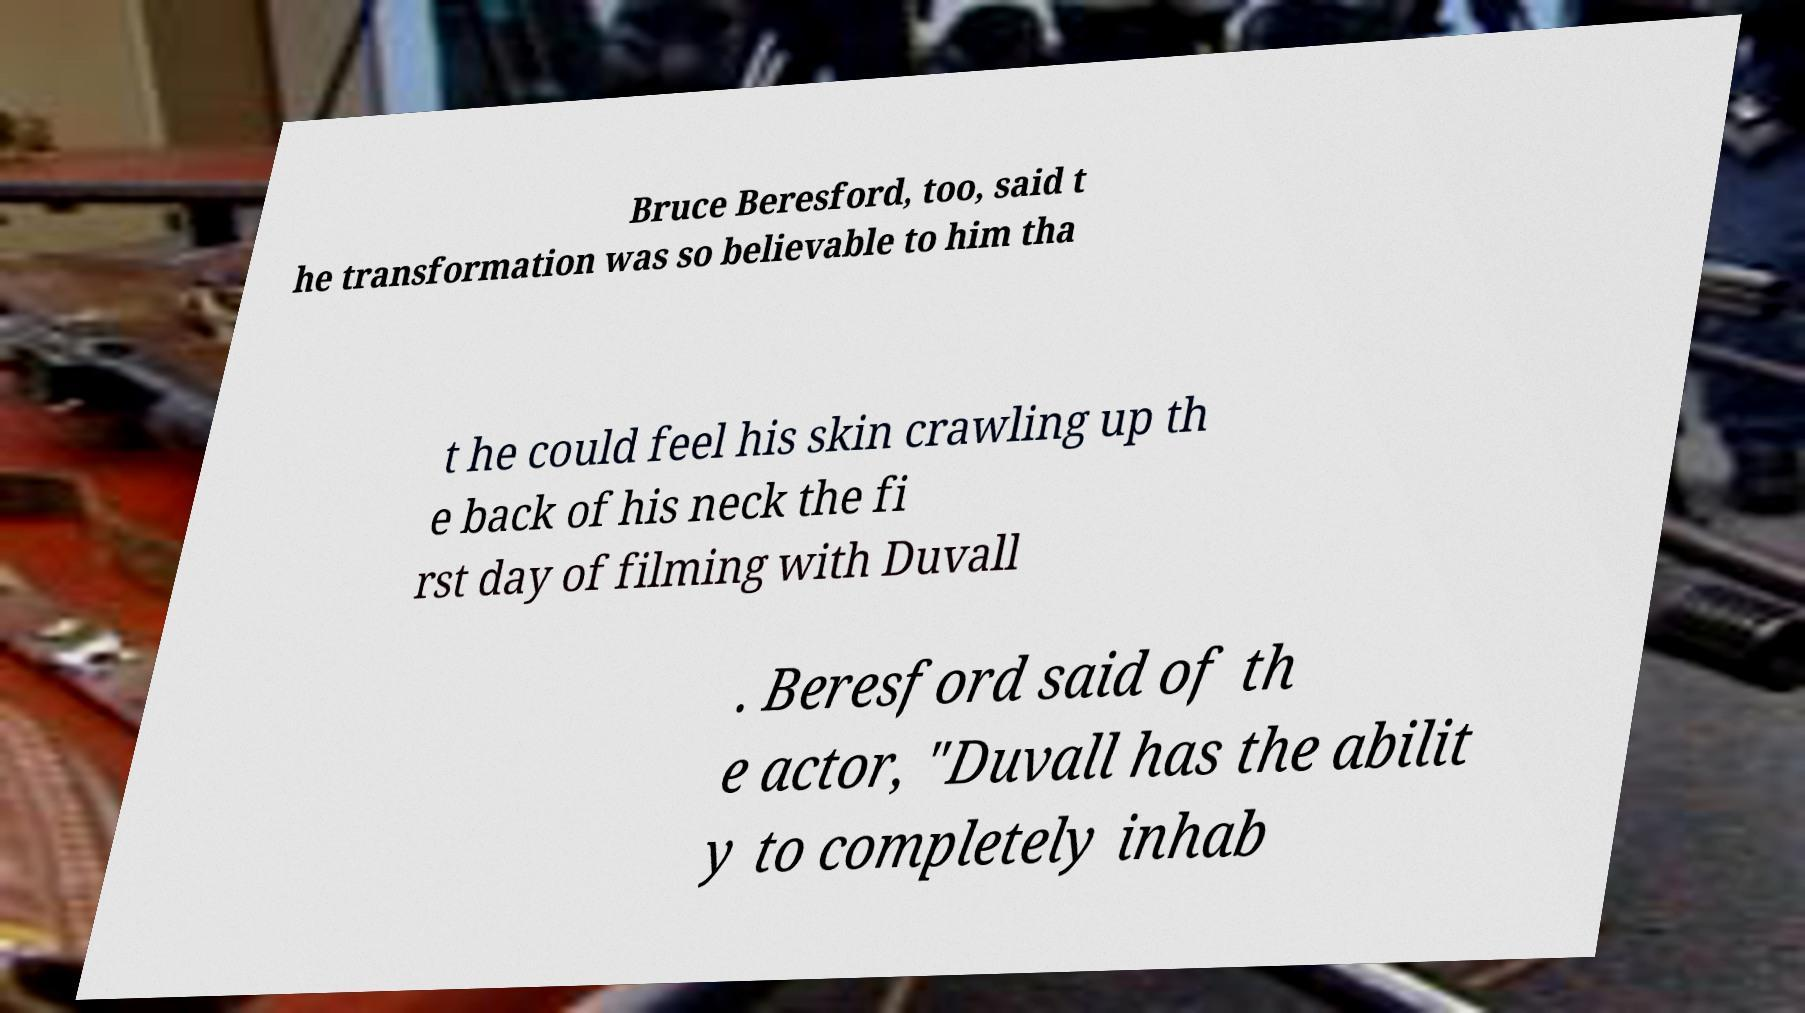I need the written content from this picture converted into text. Can you do that? Bruce Beresford, too, said t he transformation was so believable to him tha t he could feel his skin crawling up th e back of his neck the fi rst day of filming with Duvall . Beresford said of th e actor, "Duvall has the abilit y to completely inhab 